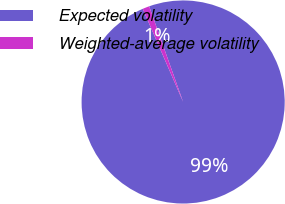<chart> <loc_0><loc_0><loc_500><loc_500><pie_chart><fcel>Expected volatility<fcel>Weighted-average volatility<nl><fcel>98.92%<fcel>1.08%<nl></chart> 